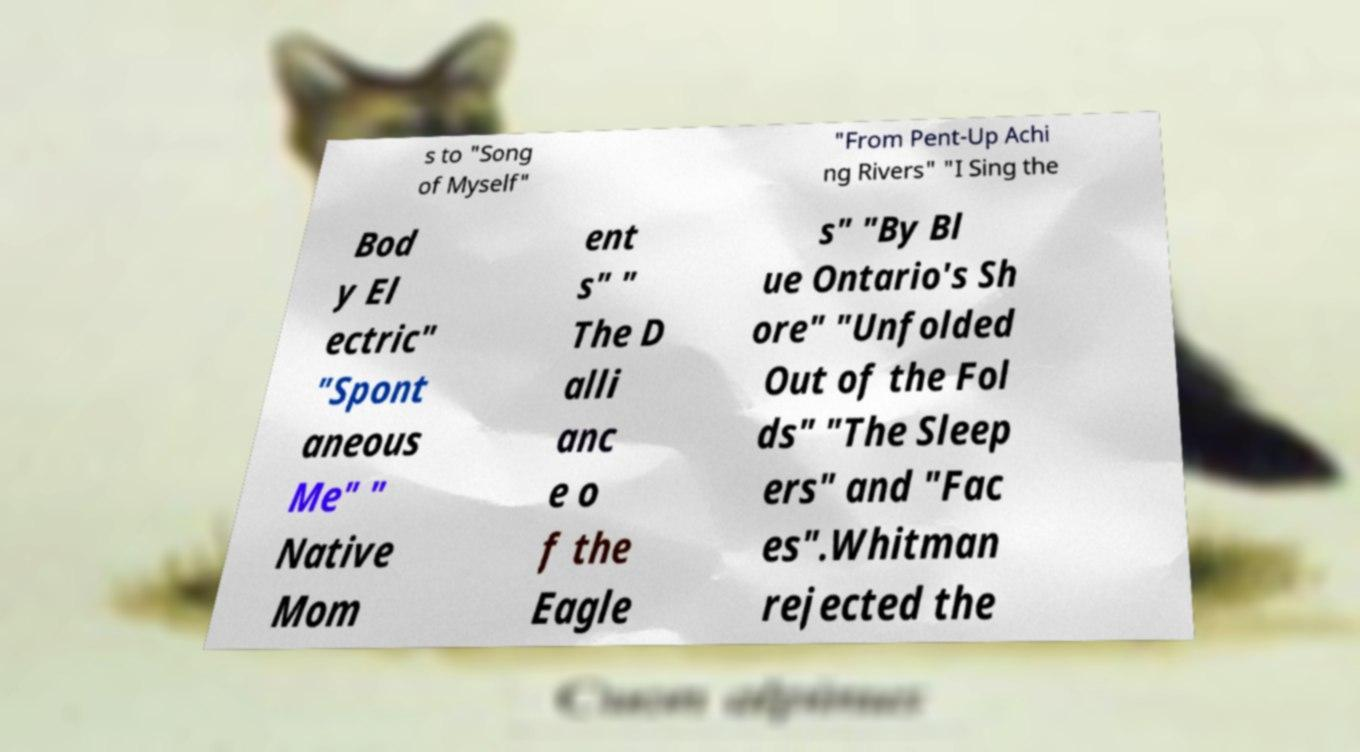I need the written content from this picture converted into text. Can you do that? s to "Song of Myself" "From Pent-Up Achi ng Rivers" "I Sing the Bod y El ectric" "Spont aneous Me" " Native Mom ent s" " The D alli anc e o f the Eagle s" "By Bl ue Ontario's Sh ore" "Unfolded Out of the Fol ds" "The Sleep ers" and "Fac es".Whitman rejected the 